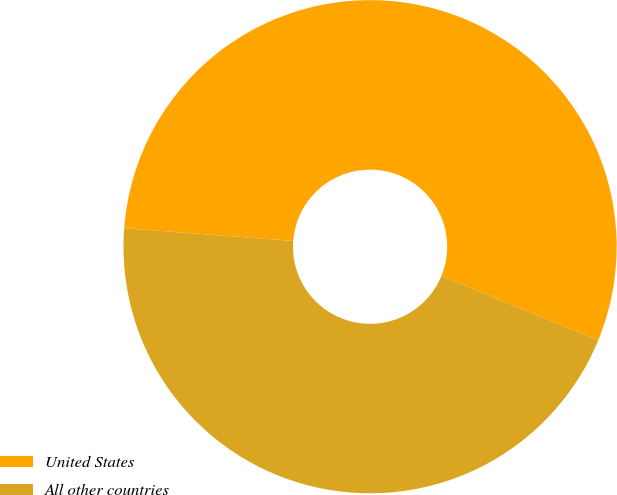<chart> <loc_0><loc_0><loc_500><loc_500><pie_chart><fcel>United States<fcel>All other countries<nl><fcel>55.0%<fcel>45.0%<nl></chart> 